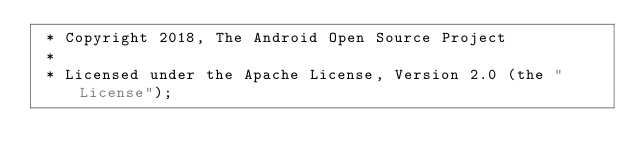Convert code to text. <code><loc_0><loc_0><loc_500><loc_500><_Kotlin_> * Copyright 2018, The Android Open Source Project
 *
 * Licensed under the Apache License, Version 2.0 (the "License");</code> 